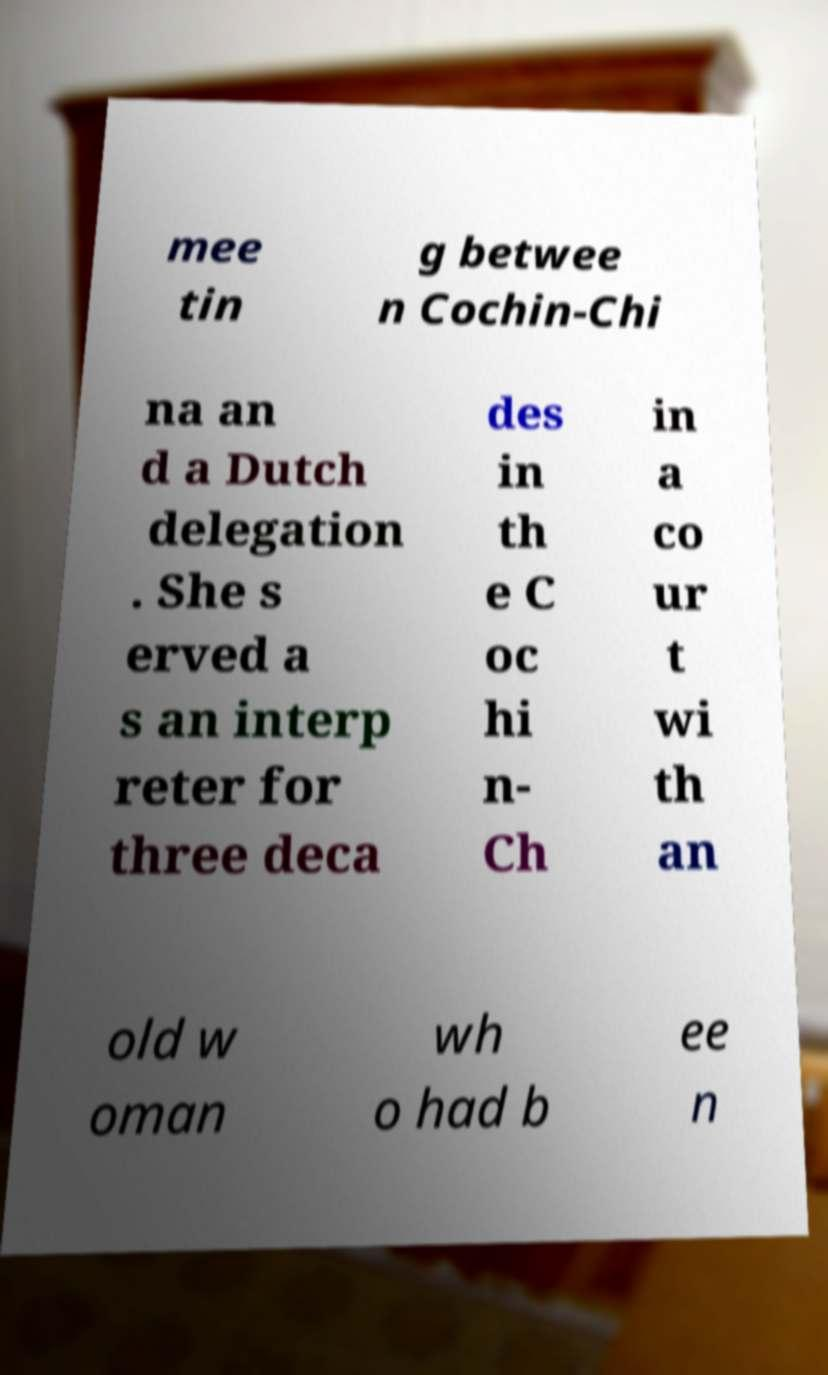Could you assist in decoding the text presented in this image and type it out clearly? mee tin g betwee n Cochin-Chi na an d a Dutch delegation . She s erved a s an interp reter for three deca des in th e C oc hi n- Ch in a co ur t wi th an old w oman wh o had b ee n 